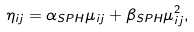<formula> <loc_0><loc_0><loc_500><loc_500>\eta _ { i j } = \alpha _ { S P H } \mu _ { i j } + \beta _ { S P H } \mu _ { i j } ^ { 2 } ,</formula> 